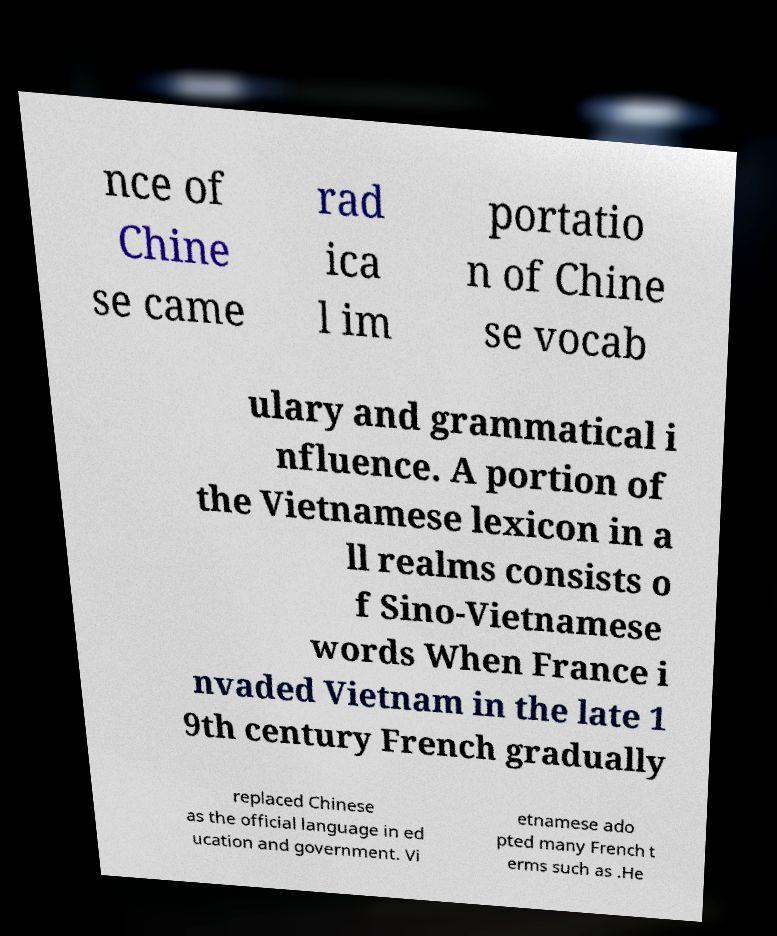Please identify and transcribe the text found in this image. nce of Chine se came rad ica l im portatio n of Chine se vocab ulary and grammatical i nfluence. A portion of the Vietnamese lexicon in a ll realms consists o f Sino-Vietnamese words When France i nvaded Vietnam in the late 1 9th century French gradually replaced Chinese as the official language in ed ucation and government. Vi etnamese ado pted many French t erms such as .He 